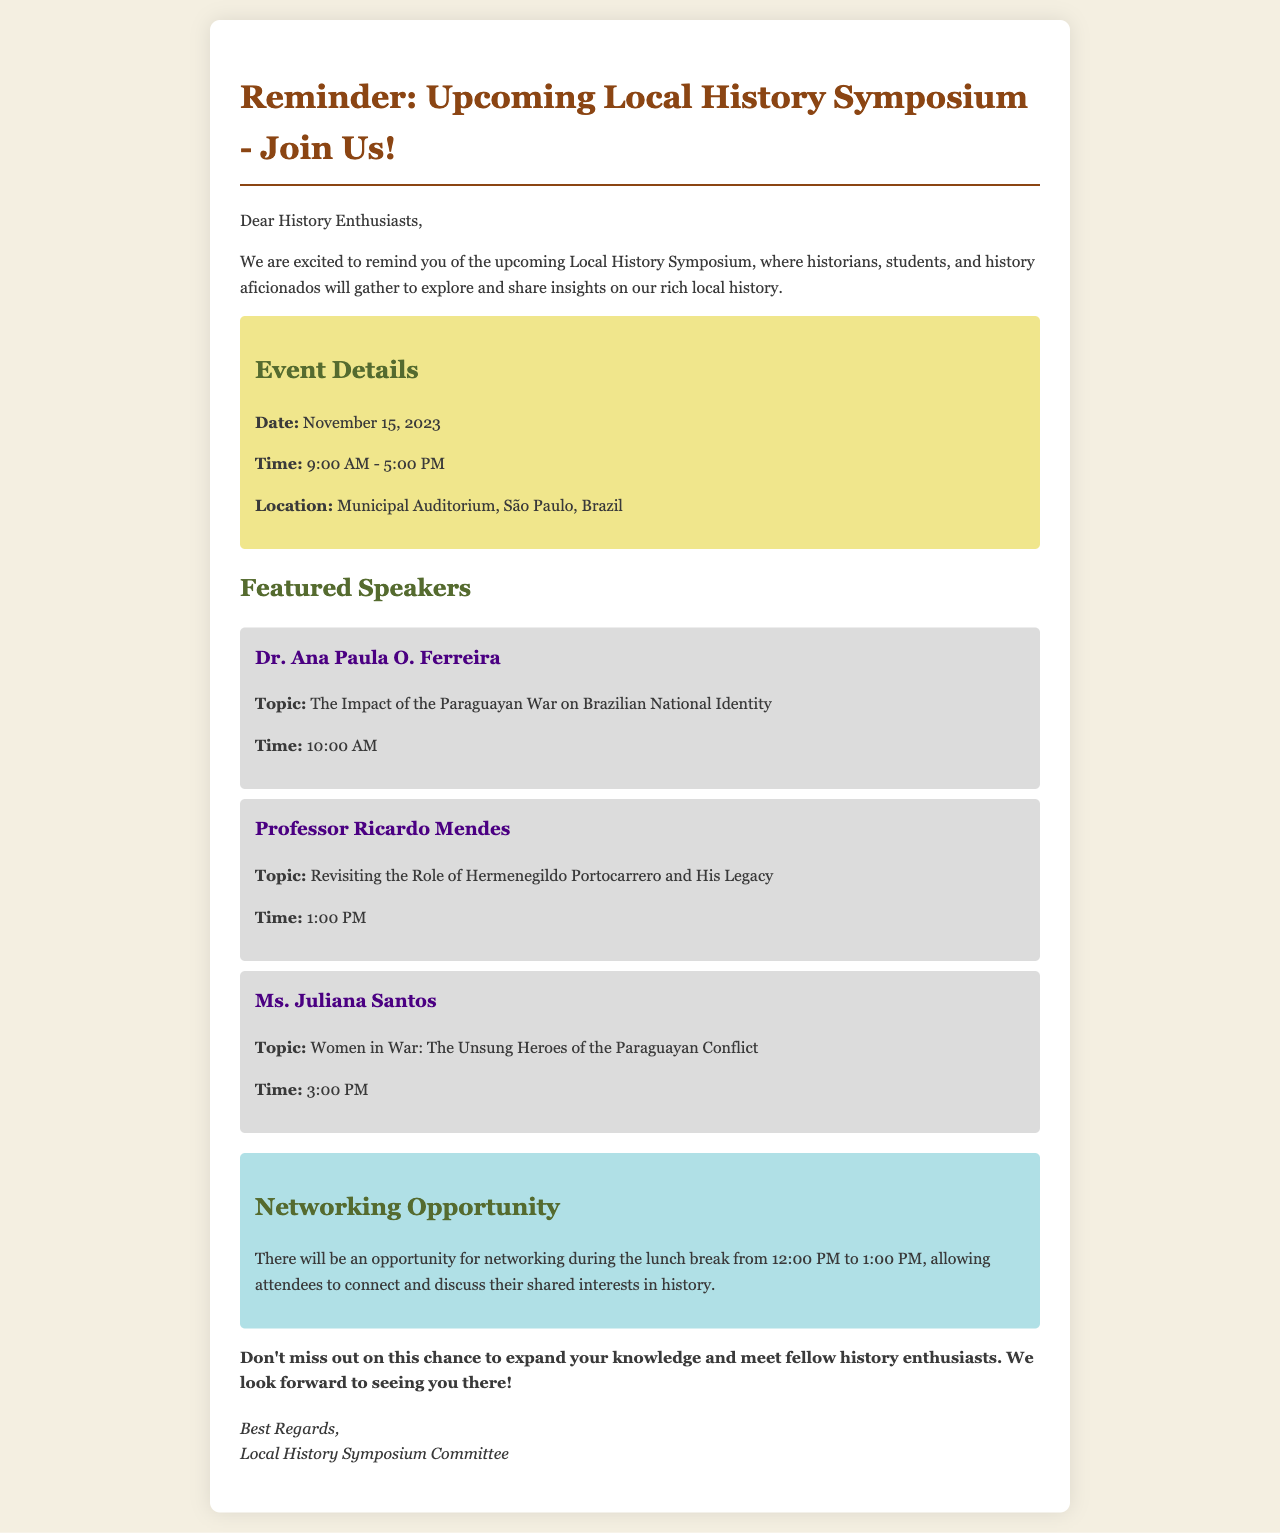What is the date of the symposium? The date of the symposium is clearly mentioned in the event details section of the document.
Answer: November 15, 2023 What time does the symposium start? The start time is specified in the event details section along with the overall timing of the event.
Answer: 9:00 AM Who is speaking at 1:00 PM? This question pertains to the schedule of speakers, and the document specifies the time along with the respective speaker.
Answer: Professor Ricardo Mendes What topic will Dr. Ana Paula O. Ferreira discuss? The document directly outlines the topics each speaker will cover, including Dr. Ferreira's.
Answer: The Impact of the Paraguayan War on Brazilian National Identity What is the location of the symposium? The location is provided in the event details section of the email.
Answer: Municipal Auditorium, São Paulo, Brazil What is the duration of the networking opportunity? The networking opportunity is mentioned in terms of time between the lunch break, which helps understand its duration clearly.
Answer: 12:00 PM to 1:00 PM What is the focus of Ms. Juliana Santos's presentation? The document explicitly states the topic of each speaker's presentation, allowing for easy identification of Ms. Santos's focus.
Answer: Women in War: The Unsung Heroes of the Paraguayan Conflict Who is the committee that sent the reminder? The closing signature of the email indicates the organization responsible for the event.
Answer: Local History Symposium Committee 